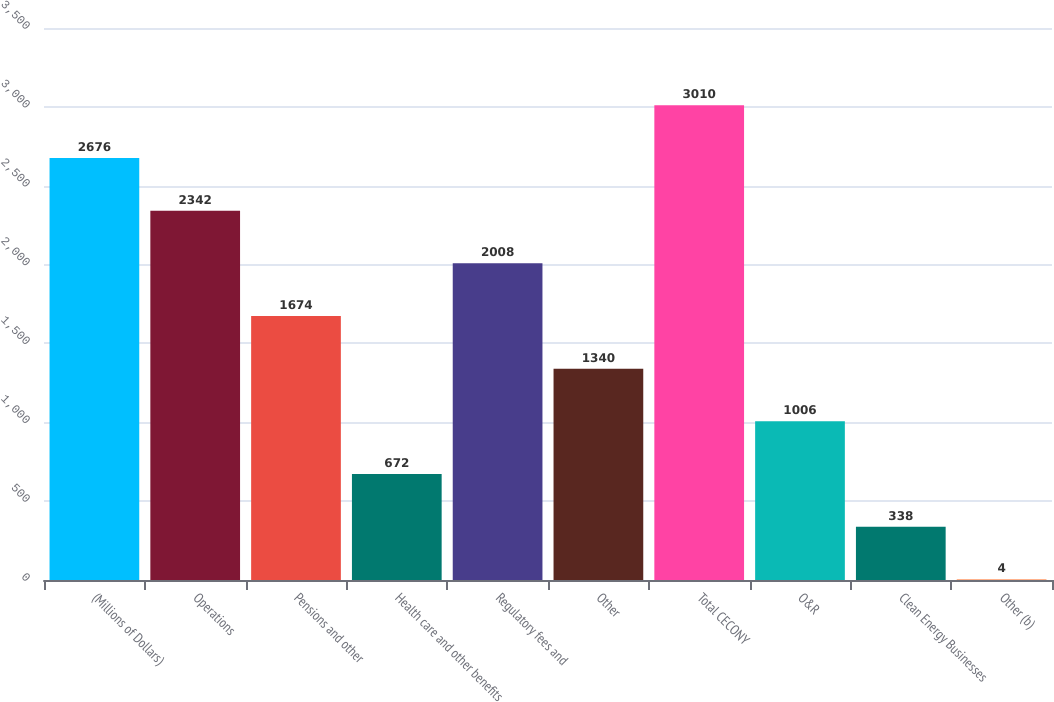Convert chart. <chart><loc_0><loc_0><loc_500><loc_500><bar_chart><fcel>(Millions of Dollars)<fcel>Operations<fcel>Pensions and other<fcel>Health care and other benefits<fcel>Regulatory fees and<fcel>Other<fcel>Total CECONY<fcel>O&R<fcel>Clean Energy Businesses<fcel>Other (b)<nl><fcel>2676<fcel>2342<fcel>1674<fcel>672<fcel>2008<fcel>1340<fcel>3010<fcel>1006<fcel>338<fcel>4<nl></chart> 